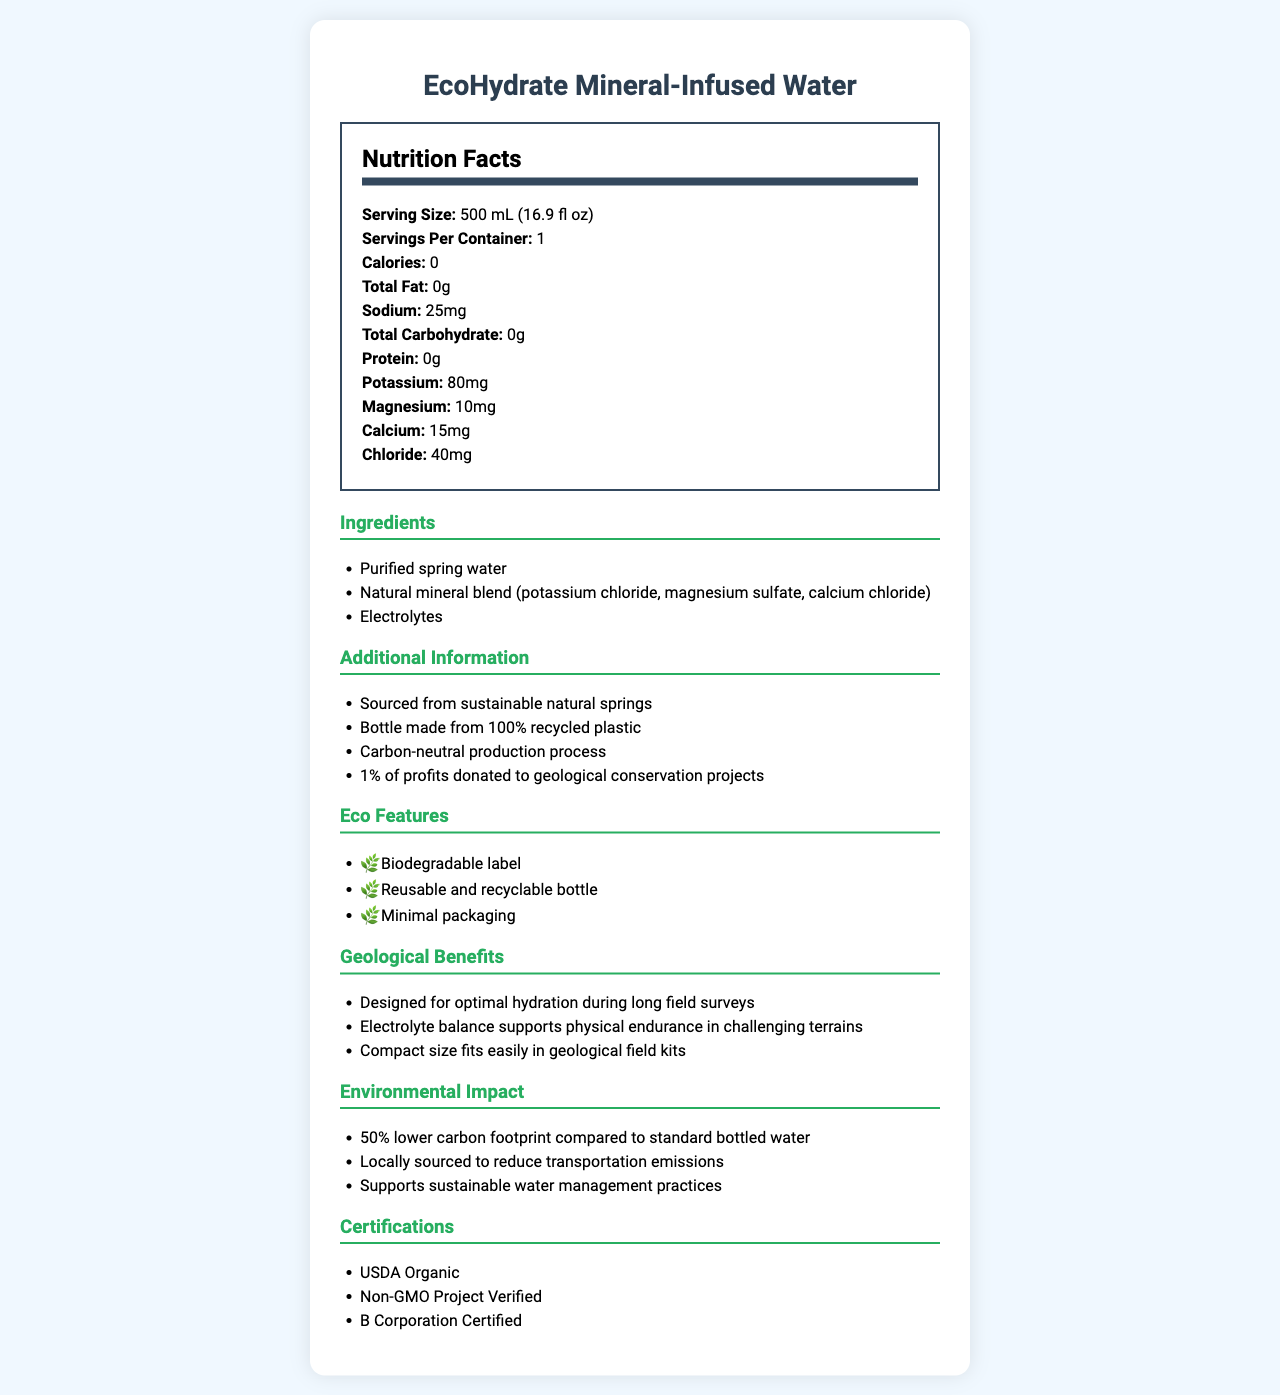What is the serving size of EcoHydrate Mineral-Infused Water? The document states the serving size is "500 mL (16.9 fl oz)" in the Nutrition Facts section.
Answer: 500 mL (16.9 fl oz) How many servings are there per container of this product? The document specifies that there are "1" servings per container in the Nutrition Facts section.
Answer: 1 How many calories are contained in one serving of EcoHydrate Mineral-Infused Water? The Nutrition Facts section indicates that the calorie count is "0".
Answer: 0 What is the total amount of potassium in one serving? According to the Nutrition Facts section, one serving contains "80mg" of potassium.
Answer: 80mg Which ingredient in EcoHydrate Mineral-Infused Water contributes to electrolytes? The ingredients section lists "Natural mineral blend (potassium chloride, magnesium sulfate, calcium chloride)" as contributors to the electrolytes.
Answer: Natural mineral blend (potassium chloride, magnesium sulfate, calcium chloride) What is the environmental contribution mentioned for this product? The additional information section states, "1% of profits donated to geological conservation projects."
Answer: 1% of profits donated to geological conservation projects What is the total sodium content in one serving of EcoHydrate Mineral-Infused Water? A. 15mg B. 25mg C. 50mg The Nutrition Facts section shows that the sodium content per serving is "25mg."
Answer: B. 25mg Which of the following certifications does EcoHydrate Mineral-Infused Water have? I. USDA Organic II. Non-GMO Project Verified III. Fair Trade Certified The certifications section lists "USDA Organic" and "Non-GMO Project Verified" but does not mention "Fair Trade Certified."
Answer: I and II Is the bottle of EcoHydrate Mineral-Infused Water made from 100% recycled plastic? The additional information section confirms that the bottle is made from "100% recycled plastic."
Answer: Yes Summarize the main idea of the document about EcoHydrate Mineral-Infused Water. The document details the nutritional content, eco-features, geological benefits, and sustainability initiatives related to EcoHydrate Mineral-Infused Water.
Answer: EcoHydrate Mineral-Infused Water is a health-focused, eco-friendly bottled water alternative designed for optimal hydration during geological surveys. It contains electrolytes and various minerals with zero calories, and it has meaningful eco features like a biodegradable label and a carbon-neutral production process. Additionally, the product supports geological conservation projects and boasts several sustainability certifications. How many grams of protein are in a serving of this water? The Nutrition Facts section clearly states that there are "0g" of protein per serving.
Answer: 0g What is the primary source of water in EcoHydrate Mineral-Infused Water? The ingredients section lists "Purified spring water" as the primary source.
Answer: Purified spring water Does this product have a higher or lower carbon footprint compared to standard bottled water? The environmental impact section mentions that the product has a "50% lower carbon footprint compared to standard bottled water."
Answer: Lower What percentage of the product's profits is donated to geological conservation projects? The additional information section indicates that "1% of profits" are donated to geological conservation projects.
Answer: 1% Is there any information provided about the flavor of EcoHydrate Mineral-Infused Water? The document does not mention the flavor of the product, only its ingredients and additives.
Answer: Not enough information 